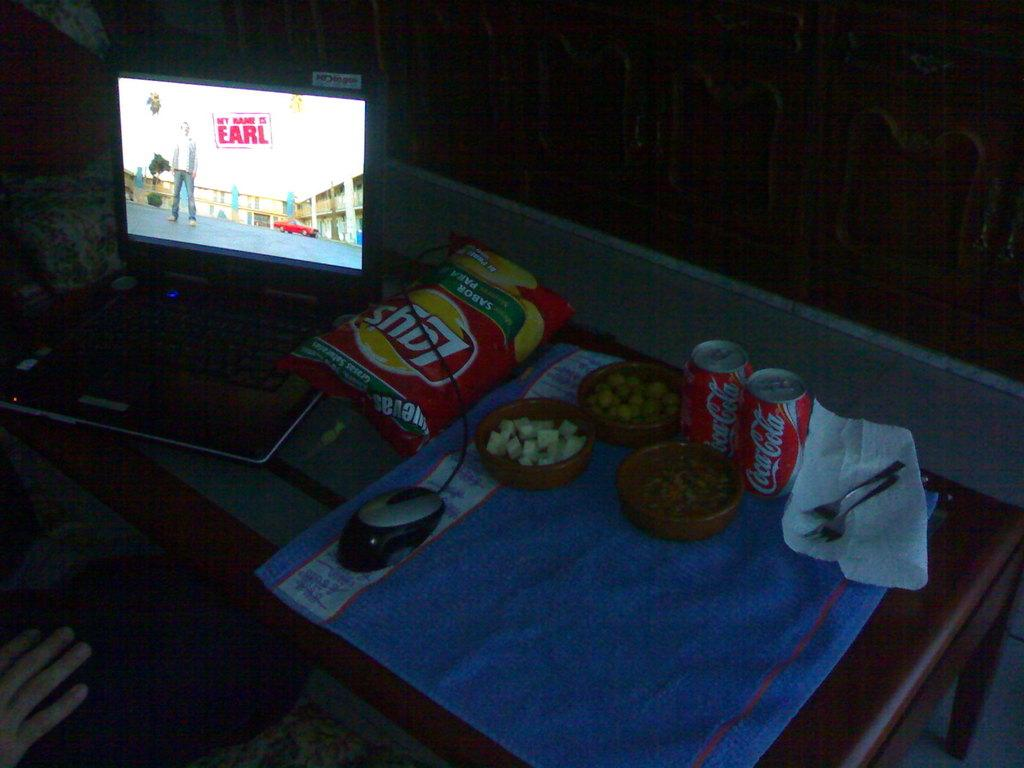<image>
Give a short and clear explanation of the subsequent image. A bag of Lay's chips and two cans of Coca-Cola are on a table. 